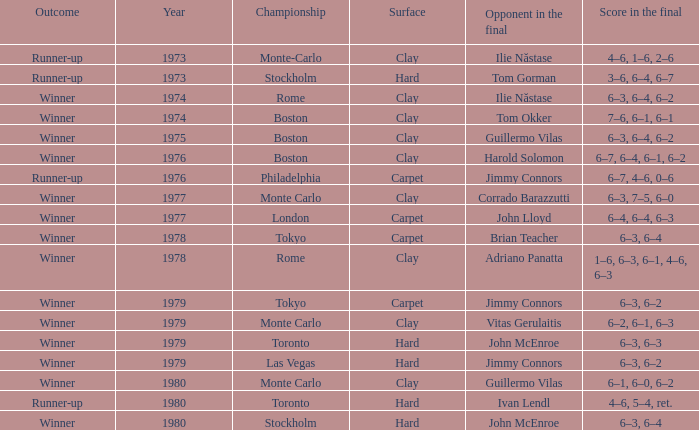For how long, in years, does a 6-3, 6-2 hard surface remain? 1.0. 